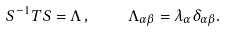Convert formula to latex. <formula><loc_0><loc_0><loc_500><loc_500>S ^ { - 1 } T S = \Lambda \, , \quad \Lambda _ { \alpha \beta } = \lambda _ { \alpha } \delta _ { \alpha \beta } .</formula> 